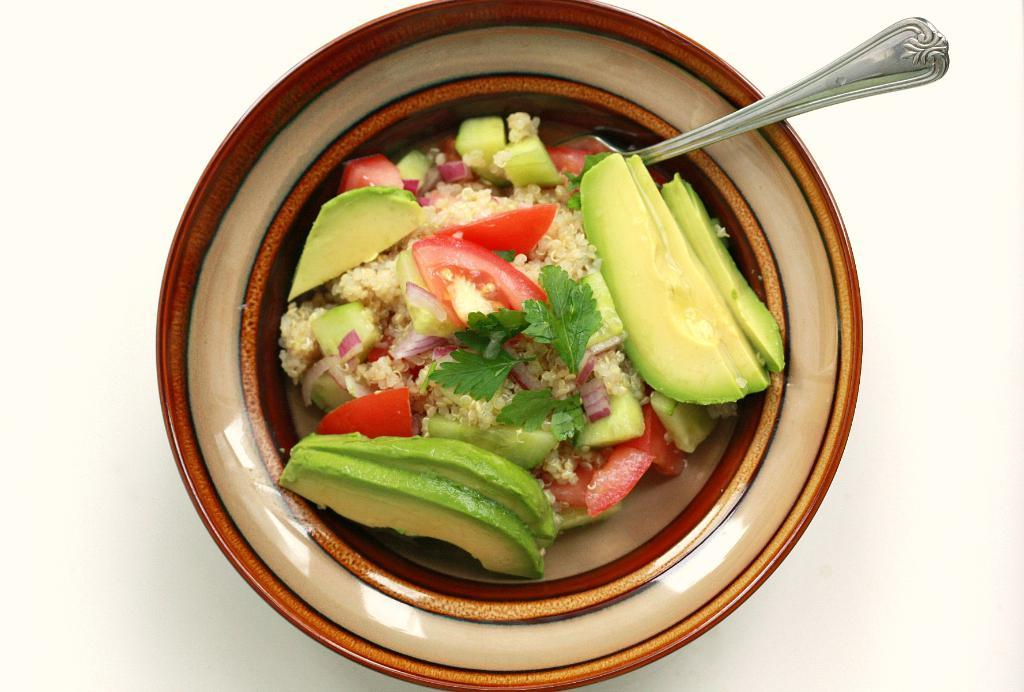What type of objects can be seen in the image? There are food items in the image. What utensil is present in the image? There is a spoon in the image. Where is the spoon located? The spoon is in a bowl. What is the bowl resting on? The bowl is on a platform. How does the pig contribute to the food preparation in the image? There is no pig present in the image, so it cannot contribute to the food preparation. 